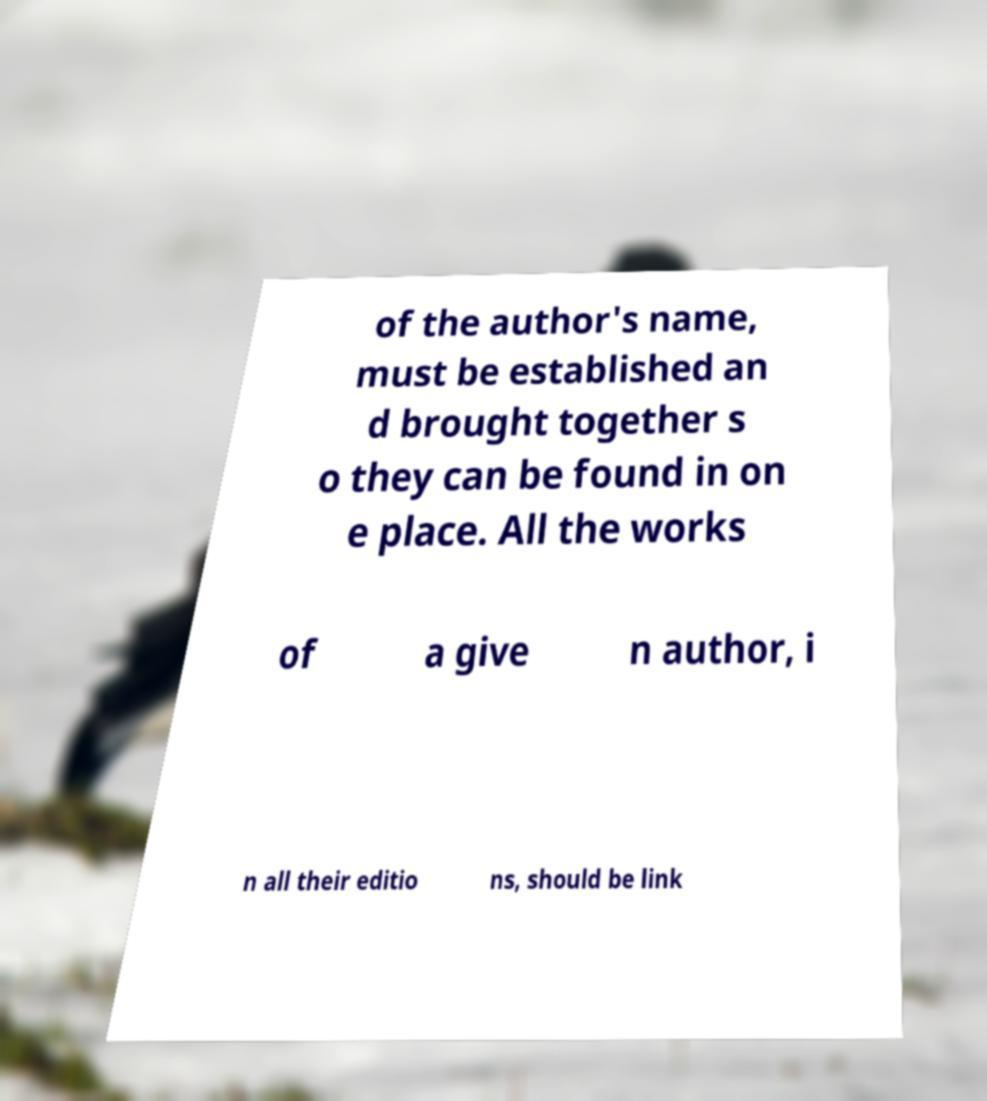There's text embedded in this image that I need extracted. Can you transcribe it verbatim? of the author's name, must be established an d brought together s o they can be found in on e place. All the works of a give n author, i n all their editio ns, should be link 